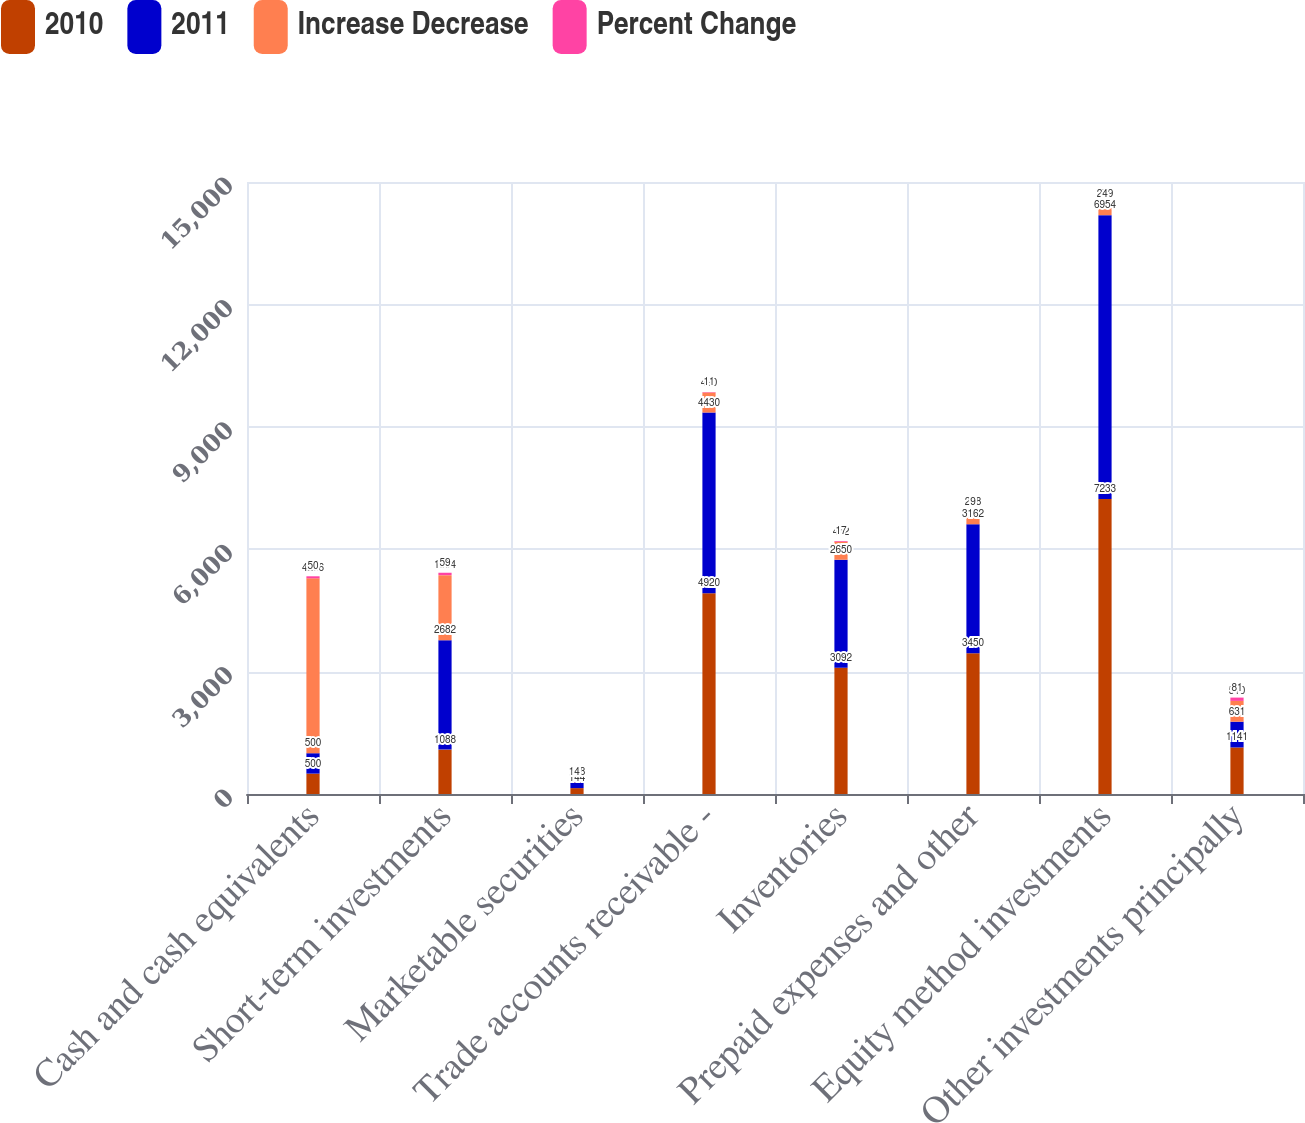Convert chart. <chart><loc_0><loc_0><loc_500><loc_500><stacked_bar_chart><ecel><fcel>Cash and cash equivalents<fcel>Short-term investments<fcel>Marketable securities<fcel>Trade accounts receivable -<fcel>Inventories<fcel>Prepaid expenses and other<fcel>Equity method investments<fcel>Other investments principally<nl><fcel>2010<fcel>500<fcel>1088<fcel>144<fcel>4920<fcel>3092<fcel>3450<fcel>7233<fcel>1141<nl><fcel>2011<fcel>500<fcel>2682<fcel>138<fcel>4430<fcel>2650<fcel>3162<fcel>6954<fcel>631<nl><fcel>Increase Decrease<fcel>4286<fcel>1594<fcel>6<fcel>490<fcel>442<fcel>288<fcel>279<fcel>510<nl><fcel>Percent Change<fcel>50<fcel>59<fcel>4<fcel>11<fcel>17<fcel>9<fcel>4<fcel>81<nl></chart> 